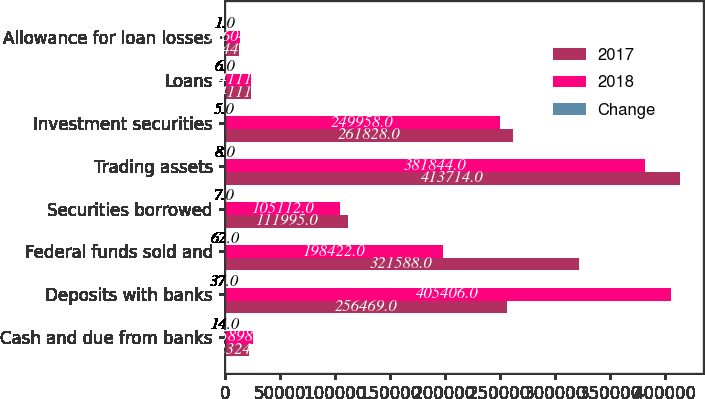Convert chart to OTSL. <chart><loc_0><loc_0><loc_500><loc_500><stacked_bar_chart><ecel><fcel>Cash and due from banks<fcel>Deposits with banks<fcel>Federal funds sold and<fcel>Securities borrowed<fcel>Trading assets<fcel>Investment securities<fcel>Loans<fcel>Allowance for loan losses<nl><fcel>2017<fcel>22324<fcel>256469<fcel>321588<fcel>111995<fcel>413714<fcel>261828<fcel>24111<fcel>13445<nl><fcel>2018<fcel>25898<fcel>405406<fcel>198422<fcel>105112<fcel>381844<fcel>249958<fcel>24111<fcel>13604<nl><fcel>Change<fcel>14<fcel>37<fcel>62<fcel>7<fcel>8<fcel>5<fcel>6<fcel>1<nl></chart> 